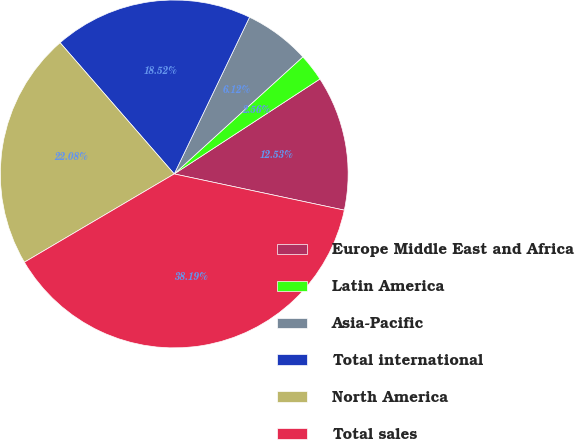Convert chart. <chart><loc_0><loc_0><loc_500><loc_500><pie_chart><fcel>Europe Middle East and Africa<fcel>Latin America<fcel>Asia-Pacific<fcel>Total international<fcel>North America<fcel>Total sales<nl><fcel>12.53%<fcel>2.56%<fcel>6.12%<fcel>18.52%<fcel>22.08%<fcel>38.19%<nl></chart> 